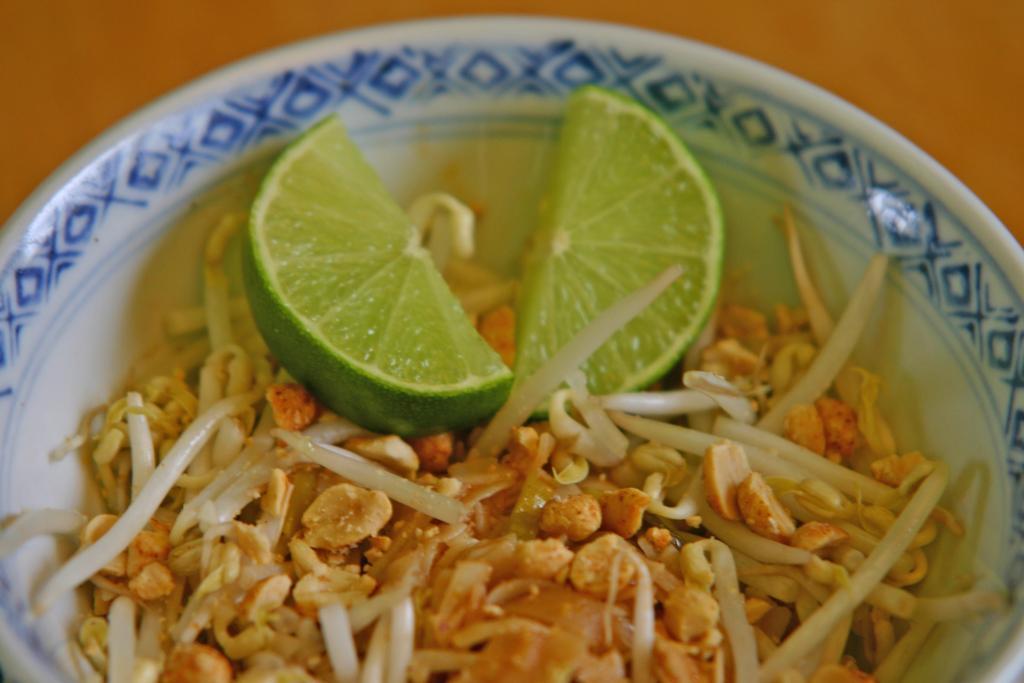How would you summarize this image in a sentence or two? In this bowl there is a food and slices of lemon. Background it is blur. 